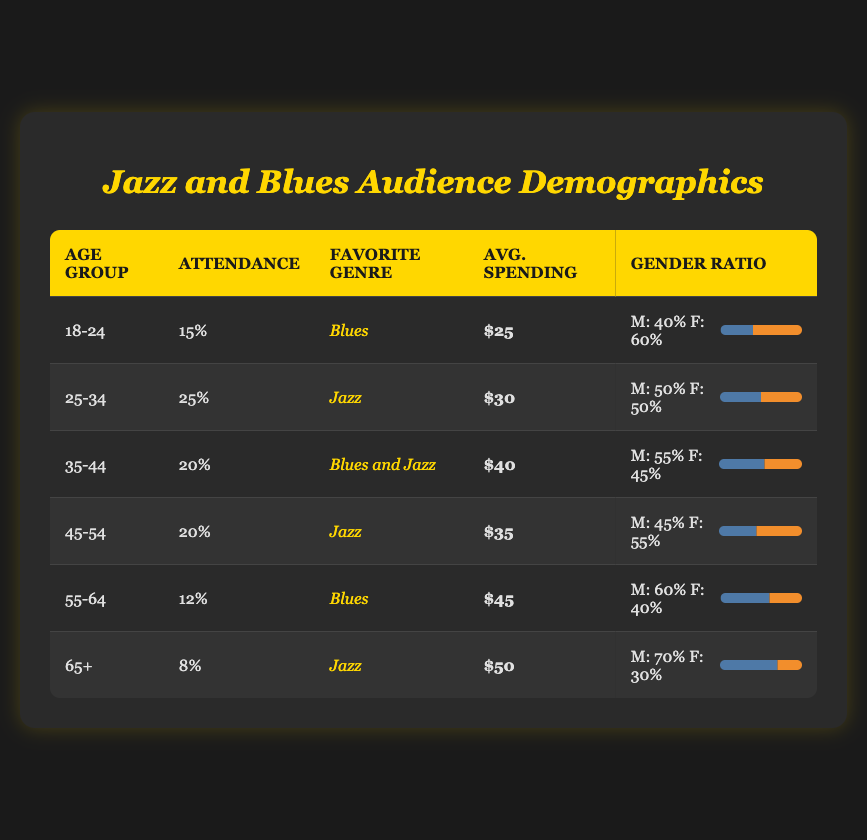What is the favorite genre of the age group 25-34? According to the table, the favorite genre for the age group 25-34 is labeled under the "Favorite Genre" column, which states "Jazz."
Answer: Jazz Which age group has the highest attendance percentage? By comparing the "Attendance" percentages across all age groups, the 25-34 age group has the highest percentage at 25%.
Answer: 25-34 What is the average spending of the audience aged 55-64? The table shows that the average spending for the age group 55-64 is marked under the "Avg. Spending" column, which reads $45.
Answer: $45 Is the gender ratio for the 18-24 age group gender-balanced? The gender ratio for the 18-24 age group is 40% male and 60% female. Since these percentages are not equal, the ratio is not considered balanced.
Answer: No What is the combined attendance percentage for the age groups that prefer Blues? The age groups that prefer Blues are 18-24 and 55-64. Their attendance percentages are 15% and 12%, respectively. When summed, it totals to 15% + 12% = 27%.
Answer: 27% How does the average spending for the 65+ age group compare to the 45-54 age group? The average spending for the 65+ age group is $50, while for the 45-54 age group it is $35. This shows that the older age group spends $15 more than the younger one in this comparison.
Answer: $15 more What percentage of males prefer Jazz in the age group 45-54? The gender ratio for the age group 45-54 indicates that 45% of the audience members are male.
Answer: 45% What age group has the lowest attendance percentage? By assessing the attendance percentages for all age groups, the lowest percentage is found in the 65+ age group at 8%.
Answer: 65+ Which age group has the highest preference for "Blues and Jazz"? According to the table, the age group 35-44 is identified as having a preference for both Blues and Jazz.
Answer: 35-44 If you combine the average spending of age groups with a focus on Jazz, do they exceed $100? The average spendings for age groups that prefer Jazz are $30 (25-34), $35 (45-54), and $50 (65+). When summed, they equal $30 + $35 + $50 = $115. Therefore, they do exceed $100.
Answer: Yes 